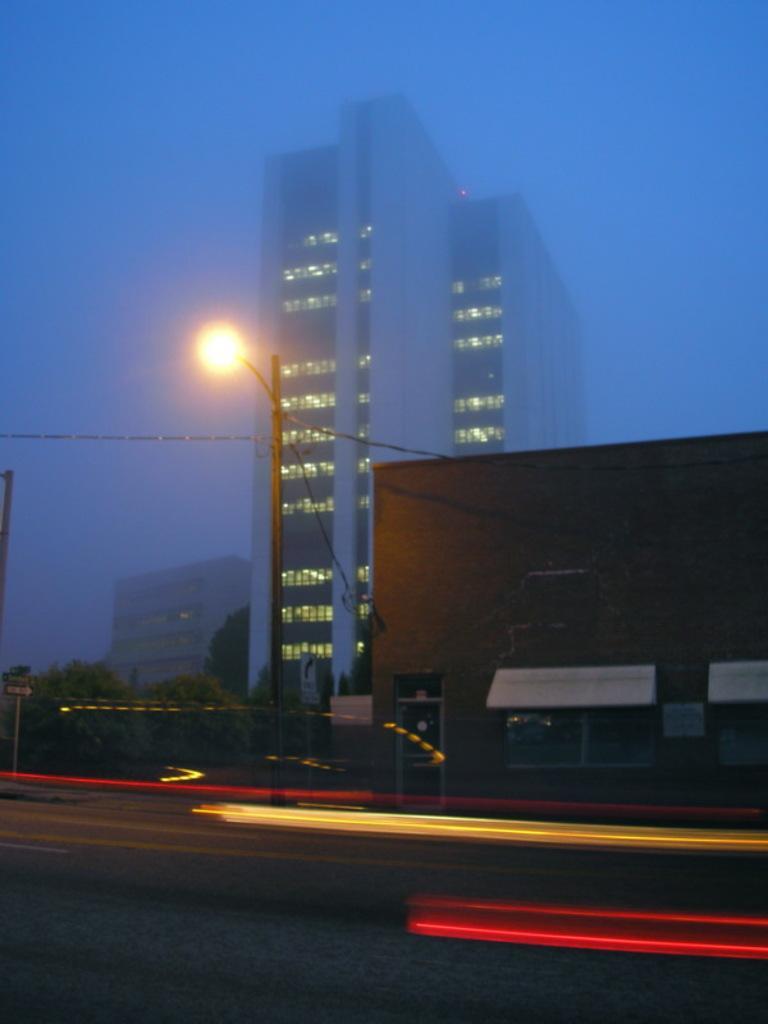How would you summarize this image in a sentence or two? In the foreground I can see the road. In the background, I can see the buildings. I can see a light pole on the side of the road. I can see the trees on the left side. I can see the blue sky. 